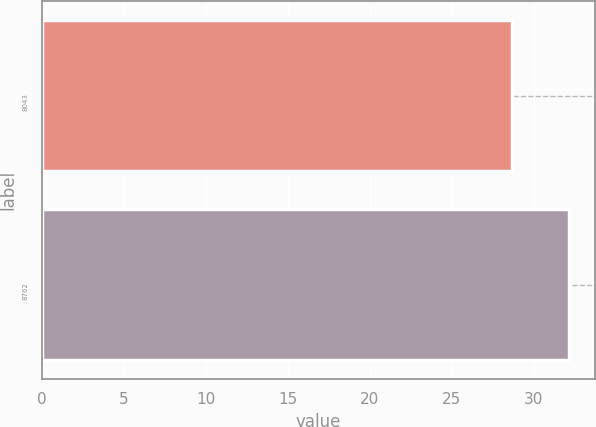Convert chart. <chart><loc_0><loc_0><loc_500><loc_500><bar_chart><fcel>8043<fcel>8762<nl><fcel>28.65<fcel>32.13<nl></chart> 